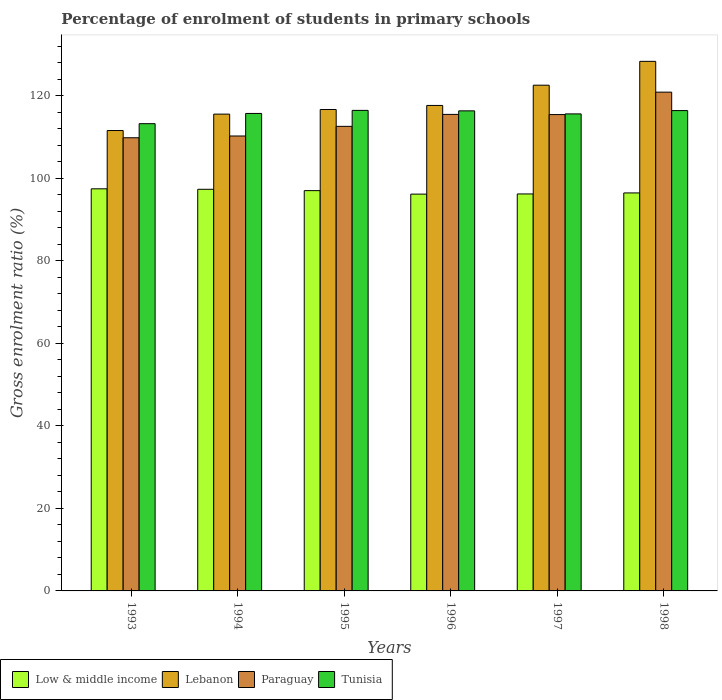How many different coloured bars are there?
Provide a succinct answer. 4. How many groups of bars are there?
Offer a terse response. 6. Are the number of bars per tick equal to the number of legend labels?
Give a very brief answer. Yes. Are the number of bars on each tick of the X-axis equal?
Offer a terse response. Yes. How many bars are there on the 3rd tick from the right?
Keep it short and to the point. 4. What is the percentage of students enrolled in primary schools in Paraguay in 1997?
Ensure brevity in your answer.  115.43. Across all years, what is the maximum percentage of students enrolled in primary schools in Low & middle income?
Provide a short and direct response. 97.44. Across all years, what is the minimum percentage of students enrolled in primary schools in Paraguay?
Your answer should be compact. 109.81. In which year was the percentage of students enrolled in primary schools in Tunisia maximum?
Provide a succinct answer. 1995. What is the total percentage of students enrolled in primary schools in Lebanon in the graph?
Offer a very short reply. 712.27. What is the difference between the percentage of students enrolled in primary schools in Lebanon in 1995 and that in 1996?
Ensure brevity in your answer.  -0.98. What is the difference between the percentage of students enrolled in primary schools in Paraguay in 1993 and the percentage of students enrolled in primary schools in Lebanon in 1995?
Offer a terse response. -6.85. What is the average percentage of students enrolled in primary schools in Lebanon per year?
Keep it short and to the point. 118.71. In the year 1993, what is the difference between the percentage of students enrolled in primary schools in Low & middle income and percentage of students enrolled in primary schools in Paraguay?
Your response must be concise. -12.37. What is the ratio of the percentage of students enrolled in primary schools in Lebanon in 1995 to that in 1996?
Provide a short and direct response. 0.99. Is the percentage of students enrolled in primary schools in Low & middle income in 1994 less than that in 1996?
Offer a terse response. No. Is the difference between the percentage of students enrolled in primary schools in Low & middle income in 1993 and 1996 greater than the difference between the percentage of students enrolled in primary schools in Paraguay in 1993 and 1996?
Give a very brief answer. Yes. What is the difference between the highest and the second highest percentage of students enrolled in primary schools in Paraguay?
Provide a short and direct response. 5.39. What is the difference between the highest and the lowest percentage of students enrolled in primary schools in Low & middle income?
Ensure brevity in your answer.  1.28. Is the sum of the percentage of students enrolled in primary schools in Paraguay in 1993 and 1998 greater than the maximum percentage of students enrolled in primary schools in Tunisia across all years?
Ensure brevity in your answer.  Yes. Is it the case that in every year, the sum of the percentage of students enrolled in primary schools in Lebanon and percentage of students enrolled in primary schools in Paraguay is greater than the sum of percentage of students enrolled in primary schools in Tunisia and percentage of students enrolled in primary schools in Low & middle income?
Ensure brevity in your answer.  No. What does the 2nd bar from the left in 1996 represents?
Your answer should be compact. Lebanon. What does the 2nd bar from the right in 1994 represents?
Your answer should be compact. Paraguay. Is it the case that in every year, the sum of the percentage of students enrolled in primary schools in Tunisia and percentage of students enrolled in primary schools in Paraguay is greater than the percentage of students enrolled in primary schools in Low & middle income?
Provide a short and direct response. Yes. How many bars are there?
Your response must be concise. 24. Are all the bars in the graph horizontal?
Ensure brevity in your answer.  No. Are the values on the major ticks of Y-axis written in scientific E-notation?
Provide a succinct answer. No. Does the graph contain grids?
Your answer should be very brief. No. Where does the legend appear in the graph?
Give a very brief answer. Bottom left. How many legend labels are there?
Your response must be concise. 4. How are the legend labels stacked?
Give a very brief answer. Horizontal. What is the title of the graph?
Offer a very short reply. Percentage of enrolment of students in primary schools. Does "Cayman Islands" appear as one of the legend labels in the graph?
Make the answer very short. No. What is the label or title of the X-axis?
Your answer should be very brief. Years. What is the Gross enrolment ratio (%) of Low & middle income in 1993?
Your response must be concise. 97.44. What is the Gross enrolment ratio (%) in Lebanon in 1993?
Ensure brevity in your answer.  111.56. What is the Gross enrolment ratio (%) in Paraguay in 1993?
Give a very brief answer. 109.81. What is the Gross enrolment ratio (%) of Tunisia in 1993?
Give a very brief answer. 113.22. What is the Gross enrolment ratio (%) in Low & middle income in 1994?
Offer a terse response. 97.32. What is the Gross enrolment ratio (%) of Lebanon in 1994?
Keep it short and to the point. 115.54. What is the Gross enrolment ratio (%) in Paraguay in 1994?
Provide a succinct answer. 110.24. What is the Gross enrolment ratio (%) in Tunisia in 1994?
Offer a very short reply. 115.7. What is the Gross enrolment ratio (%) of Low & middle income in 1995?
Your answer should be very brief. 97. What is the Gross enrolment ratio (%) of Lebanon in 1995?
Your answer should be very brief. 116.66. What is the Gross enrolment ratio (%) of Paraguay in 1995?
Provide a short and direct response. 112.57. What is the Gross enrolment ratio (%) in Tunisia in 1995?
Keep it short and to the point. 116.44. What is the Gross enrolment ratio (%) of Low & middle income in 1996?
Your response must be concise. 96.15. What is the Gross enrolment ratio (%) in Lebanon in 1996?
Give a very brief answer. 117.64. What is the Gross enrolment ratio (%) of Paraguay in 1996?
Give a very brief answer. 115.47. What is the Gross enrolment ratio (%) in Tunisia in 1996?
Make the answer very short. 116.33. What is the Gross enrolment ratio (%) of Low & middle income in 1997?
Offer a terse response. 96.2. What is the Gross enrolment ratio (%) of Lebanon in 1997?
Offer a very short reply. 122.55. What is the Gross enrolment ratio (%) of Paraguay in 1997?
Keep it short and to the point. 115.43. What is the Gross enrolment ratio (%) in Tunisia in 1997?
Give a very brief answer. 115.59. What is the Gross enrolment ratio (%) in Low & middle income in 1998?
Provide a short and direct response. 96.44. What is the Gross enrolment ratio (%) of Lebanon in 1998?
Keep it short and to the point. 128.32. What is the Gross enrolment ratio (%) of Paraguay in 1998?
Provide a succinct answer. 120.86. What is the Gross enrolment ratio (%) of Tunisia in 1998?
Make the answer very short. 116.39. Across all years, what is the maximum Gross enrolment ratio (%) of Low & middle income?
Give a very brief answer. 97.44. Across all years, what is the maximum Gross enrolment ratio (%) in Lebanon?
Make the answer very short. 128.32. Across all years, what is the maximum Gross enrolment ratio (%) of Paraguay?
Ensure brevity in your answer.  120.86. Across all years, what is the maximum Gross enrolment ratio (%) in Tunisia?
Make the answer very short. 116.44. Across all years, what is the minimum Gross enrolment ratio (%) of Low & middle income?
Offer a terse response. 96.15. Across all years, what is the minimum Gross enrolment ratio (%) of Lebanon?
Offer a terse response. 111.56. Across all years, what is the minimum Gross enrolment ratio (%) in Paraguay?
Keep it short and to the point. 109.81. Across all years, what is the minimum Gross enrolment ratio (%) of Tunisia?
Your response must be concise. 113.22. What is the total Gross enrolment ratio (%) in Low & middle income in the graph?
Ensure brevity in your answer.  580.55. What is the total Gross enrolment ratio (%) in Lebanon in the graph?
Keep it short and to the point. 712.27. What is the total Gross enrolment ratio (%) of Paraguay in the graph?
Give a very brief answer. 684.38. What is the total Gross enrolment ratio (%) of Tunisia in the graph?
Your response must be concise. 693.68. What is the difference between the Gross enrolment ratio (%) in Low & middle income in 1993 and that in 1994?
Your answer should be compact. 0.11. What is the difference between the Gross enrolment ratio (%) in Lebanon in 1993 and that in 1994?
Ensure brevity in your answer.  -3.98. What is the difference between the Gross enrolment ratio (%) in Paraguay in 1993 and that in 1994?
Ensure brevity in your answer.  -0.43. What is the difference between the Gross enrolment ratio (%) in Tunisia in 1993 and that in 1994?
Keep it short and to the point. -2.48. What is the difference between the Gross enrolment ratio (%) in Low & middle income in 1993 and that in 1995?
Make the answer very short. 0.44. What is the difference between the Gross enrolment ratio (%) of Lebanon in 1993 and that in 1995?
Your response must be concise. -5.09. What is the difference between the Gross enrolment ratio (%) of Paraguay in 1993 and that in 1995?
Provide a short and direct response. -2.76. What is the difference between the Gross enrolment ratio (%) of Tunisia in 1993 and that in 1995?
Keep it short and to the point. -3.22. What is the difference between the Gross enrolment ratio (%) of Low & middle income in 1993 and that in 1996?
Your response must be concise. 1.28. What is the difference between the Gross enrolment ratio (%) of Lebanon in 1993 and that in 1996?
Offer a terse response. -6.07. What is the difference between the Gross enrolment ratio (%) of Paraguay in 1993 and that in 1996?
Your response must be concise. -5.66. What is the difference between the Gross enrolment ratio (%) in Tunisia in 1993 and that in 1996?
Ensure brevity in your answer.  -3.11. What is the difference between the Gross enrolment ratio (%) of Low & middle income in 1993 and that in 1997?
Offer a very short reply. 1.24. What is the difference between the Gross enrolment ratio (%) in Lebanon in 1993 and that in 1997?
Your response must be concise. -10.98. What is the difference between the Gross enrolment ratio (%) of Paraguay in 1993 and that in 1997?
Make the answer very short. -5.62. What is the difference between the Gross enrolment ratio (%) of Tunisia in 1993 and that in 1997?
Offer a very short reply. -2.37. What is the difference between the Gross enrolment ratio (%) in Low & middle income in 1993 and that in 1998?
Offer a terse response. 1. What is the difference between the Gross enrolment ratio (%) in Lebanon in 1993 and that in 1998?
Your answer should be very brief. -16.76. What is the difference between the Gross enrolment ratio (%) of Paraguay in 1993 and that in 1998?
Offer a terse response. -11.05. What is the difference between the Gross enrolment ratio (%) of Tunisia in 1993 and that in 1998?
Your answer should be very brief. -3.17. What is the difference between the Gross enrolment ratio (%) in Low & middle income in 1994 and that in 1995?
Keep it short and to the point. 0.33. What is the difference between the Gross enrolment ratio (%) in Lebanon in 1994 and that in 1995?
Make the answer very short. -1.12. What is the difference between the Gross enrolment ratio (%) in Paraguay in 1994 and that in 1995?
Offer a very short reply. -2.34. What is the difference between the Gross enrolment ratio (%) of Tunisia in 1994 and that in 1995?
Keep it short and to the point. -0.74. What is the difference between the Gross enrolment ratio (%) in Low & middle income in 1994 and that in 1996?
Offer a very short reply. 1.17. What is the difference between the Gross enrolment ratio (%) of Lebanon in 1994 and that in 1996?
Provide a succinct answer. -2.1. What is the difference between the Gross enrolment ratio (%) in Paraguay in 1994 and that in 1996?
Keep it short and to the point. -5.23. What is the difference between the Gross enrolment ratio (%) in Tunisia in 1994 and that in 1996?
Provide a succinct answer. -0.63. What is the difference between the Gross enrolment ratio (%) in Low & middle income in 1994 and that in 1997?
Give a very brief answer. 1.13. What is the difference between the Gross enrolment ratio (%) in Lebanon in 1994 and that in 1997?
Offer a very short reply. -7.01. What is the difference between the Gross enrolment ratio (%) in Paraguay in 1994 and that in 1997?
Ensure brevity in your answer.  -5.19. What is the difference between the Gross enrolment ratio (%) of Tunisia in 1994 and that in 1997?
Make the answer very short. 0.11. What is the difference between the Gross enrolment ratio (%) in Low & middle income in 1994 and that in 1998?
Keep it short and to the point. 0.88. What is the difference between the Gross enrolment ratio (%) of Lebanon in 1994 and that in 1998?
Offer a very short reply. -12.78. What is the difference between the Gross enrolment ratio (%) of Paraguay in 1994 and that in 1998?
Ensure brevity in your answer.  -10.62. What is the difference between the Gross enrolment ratio (%) in Tunisia in 1994 and that in 1998?
Offer a very short reply. -0.69. What is the difference between the Gross enrolment ratio (%) of Low & middle income in 1995 and that in 1996?
Your response must be concise. 0.84. What is the difference between the Gross enrolment ratio (%) of Lebanon in 1995 and that in 1996?
Your response must be concise. -0.98. What is the difference between the Gross enrolment ratio (%) of Paraguay in 1995 and that in 1996?
Offer a terse response. -2.9. What is the difference between the Gross enrolment ratio (%) in Tunisia in 1995 and that in 1996?
Offer a terse response. 0.11. What is the difference between the Gross enrolment ratio (%) in Low & middle income in 1995 and that in 1997?
Offer a terse response. 0.8. What is the difference between the Gross enrolment ratio (%) of Lebanon in 1995 and that in 1997?
Provide a short and direct response. -5.89. What is the difference between the Gross enrolment ratio (%) in Paraguay in 1995 and that in 1997?
Make the answer very short. -2.86. What is the difference between the Gross enrolment ratio (%) in Tunisia in 1995 and that in 1997?
Make the answer very short. 0.85. What is the difference between the Gross enrolment ratio (%) of Low & middle income in 1995 and that in 1998?
Your answer should be compact. 0.56. What is the difference between the Gross enrolment ratio (%) of Lebanon in 1995 and that in 1998?
Ensure brevity in your answer.  -11.67. What is the difference between the Gross enrolment ratio (%) of Paraguay in 1995 and that in 1998?
Give a very brief answer. -8.29. What is the difference between the Gross enrolment ratio (%) in Tunisia in 1995 and that in 1998?
Your response must be concise. 0.05. What is the difference between the Gross enrolment ratio (%) of Low & middle income in 1996 and that in 1997?
Offer a very short reply. -0.04. What is the difference between the Gross enrolment ratio (%) of Lebanon in 1996 and that in 1997?
Give a very brief answer. -4.91. What is the difference between the Gross enrolment ratio (%) in Paraguay in 1996 and that in 1997?
Ensure brevity in your answer.  0.04. What is the difference between the Gross enrolment ratio (%) of Tunisia in 1996 and that in 1997?
Offer a very short reply. 0.74. What is the difference between the Gross enrolment ratio (%) in Low & middle income in 1996 and that in 1998?
Keep it short and to the point. -0.29. What is the difference between the Gross enrolment ratio (%) in Lebanon in 1996 and that in 1998?
Provide a short and direct response. -10.69. What is the difference between the Gross enrolment ratio (%) of Paraguay in 1996 and that in 1998?
Ensure brevity in your answer.  -5.39. What is the difference between the Gross enrolment ratio (%) of Tunisia in 1996 and that in 1998?
Keep it short and to the point. -0.06. What is the difference between the Gross enrolment ratio (%) of Low & middle income in 1997 and that in 1998?
Your answer should be very brief. -0.24. What is the difference between the Gross enrolment ratio (%) of Lebanon in 1997 and that in 1998?
Keep it short and to the point. -5.78. What is the difference between the Gross enrolment ratio (%) of Paraguay in 1997 and that in 1998?
Your answer should be compact. -5.43. What is the difference between the Gross enrolment ratio (%) of Tunisia in 1997 and that in 1998?
Offer a terse response. -0.8. What is the difference between the Gross enrolment ratio (%) of Low & middle income in 1993 and the Gross enrolment ratio (%) of Lebanon in 1994?
Offer a terse response. -18.1. What is the difference between the Gross enrolment ratio (%) of Low & middle income in 1993 and the Gross enrolment ratio (%) of Paraguay in 1994?
Your response must be concise. -12.8. What is the difference between the Gross enrolment ratio (%) of Low & middle income in 1993 and the Gross enrolment ratio (%) of Tunisia in 1994?
Provide a short and direct response. -18.26. What is the difference between the Gross enrolment ratio (%) in Lebanon in 1993 and the Gross enrolment ratio (%) in Paraguay in 1994?
Provide a short and direct response. 1.33. What is the difference between the Gross enrolment ratio (%) of Lebanon in 1993 and the Gross enrolment ratio (%) of Tunisia in 1994?
Offer a terse response. -4.14. What is the difference between the Gross enrolment ratio (%) in Paraguay in 1993 and the Gross enrolment ratio (%) in Tunisia in 1994?
Provide a short and direct response. -5.89. What is the difference between the Gross enrolment ratio (%) in Low & middle income in 1993 and the Gross enrolment ratio (%) in Lebanon in 1995?
Provide a succinct answer. -19.22. What is the difference between the Gross enrolment ratio (%) of Low & middle income in 1993 and the Gross enrolment ratio (%) of Paraguay in 1995?
Your response must be concise. -15.14. What is the difference between the Gross enrolment ratio (%) in Low & middle income in 1993 and the Gross enrolment ratio (%) in Tunisia in 1995?
Give a very brief answer. -19.01. What is the difference between the Gross enrolment ratio (%) in Lebanon in 1993 and the Gross enrolment ratio (%) in Paraguay in 1995?
Your answer should be compact. -1.01. What is the difference between the Gross enrolment ratio (%) of Lebanon in 1993 and the Gross enrolment ratio (%) of Tunisia in 1995?
Offer a very short reply. -4.88. What is the difference between the Gross enrolment ratio (%) of Paraguay in 1993 and the Gross enrolment ratio (%) of Tunisia in 1995?
Your answer should be compact. -6.63. What is the difference between the Gross enrolment ratio (%) of Low & middle income in 1993 and the Gross enrolment ratio (%) of Lebanon in 1996?
Offer a terse response. -20.2. What is the difference between the Gross enrolment ratio (%) of Low & middle income in 1993 and the Gross enrolment ratio (%) of Paraguay in 1996?
Your answer should be very brief. -18.03. What is the difference between the Gross enrolment ratio (%) of Low & middle income in 1993 and the Gross enrolment ratio (%) of Tunisia in 1996?
Provide a succinct answer. -18.89. What is the difference between the Gross enrolment ratio (%) in Lebanon in 1993 and the Gross enrolment ratio (%) in Paraguay in 1996?
Keep it short and to the point. -3.9. What is the difference between the Gross enrolment ratio (%) in Lebanon in 1993 and the Gross enrolment ratio (%) in Tunisia in 1996?
Your answer should be compact. -4.76. What is the difference between the Gross enrolment ratio (%) of Paraguay in 1993 and the Gross enrolment ratio (%) of Tunisia in 1996?
Make the answer very short. -6.52. What is the difference between the Gross enrolment ratio (%) of Low & middle income in 1993 and the Gross enrolment ratio (%) of Lebanon in 1997?
Offer a terse response. -25.11. What is the difference between the Gross enrolment ratio (%) of Low & middle income in 1993 and the Gross enrolment ratio (%) of Paraguay in 1997?
Give a very brief answer. -17.99. What is the difference between the Gross enrolment ratio (%) in Low & middle income in 1993 and the Gross enrolment ratio (%) in Tunisia in 1997?
Keep it short and to the point. -18.15. What is the difference between the Gross enrolment ratio (%) of Lebanon in 1993 and the Gross enrolment ratio (%) of Paraguay in 1997?
Offer a terse response. -3.87. What is the difference between the Gross enrolment ratio (%) of Lebanon in 1993 and the Gross enrolment ratio (%) of Tunisia in 1997?
Provide a short and direct response. -4.03. What is the difference between the Gross enrolment ratio (%) of Paraguay in 1993 and the Gross enrolment ratio (%) of Tunisia in 1997?
Make the answer very short. -5.78. What is the difference between the Gross enrolment ratio (%) of Low & middle income in 1993 and the Gross enrolment ratio (%) of Lebanon in 1998?
Offer a terse response. -30.89. What is the difference between the Gross enrolment ratio (%) of Low & middle income in 1993 and the Gross enrolment ratio (%) of Paraguay in 1998?
Offer a very short reply. -23.42. What is the difference between the Gross enrolment ratio (%) in Low & middle income in 1993 and the Gross enrolment ratio (%) in Tunisia in 1998?
Offer a very short reply. -18.96. What is the difference between the Gross enrolment ratio (%) in Lebanon in 1993 and the Gross enrolment ratio (%) in Paraguay in 1998?
Provide a short and direct response. -9.3. What is the difference between the Gross enrolment ratio (%) of Lebanon in 1993 and the Gross enrolment ratio (%) of Tunisia in 1998?
Provide a succinct answer. -4.83. What is the difference between the Gross enrolment ratio (%) of Paraguay in 1993 and the Gross enrolment ratio (%) of Tunisia in 1998?
Provide a short and direct response. -6.58. What is the difference between the Gross enrolment ratio (%) in Low & middle income in 1994 and the Gross enrolment ratio (%) in Lebanon in 1995?
Offer a terse response. -19.33. What is the difference between the Gross enrolment ratio (%) in Low & middle income in 1994 and the Gross enrolment ratio (%) in Paraguay in 1995?
Provide a succinct answer. -15.25. What is the difference between the Gross enrolment ratio (%) in Low & middle income in 1994 and the Gross enrolment ratio (%) in Tunisia in 1995?
Ensure brevity in your answer.  -19.12. What is the difference between the Gross enrolment ratio (%) in Lebanon in 1994 and the Gross enrolment ratio (%) in Paraguay in 1995?
Give a very brief answer. 2.97. What is the difference between the Gross enrolment ratio (%) in Lebanon in 1994 and the Gross enrolment ratio (%) in Tunisia in 1995?
Offer a terse response. -0.9. What is the difference between the Gross enrolment ratio (%) in Paraguay in 1994 and the Gross enrolment ratio (%) in Tunisia in 1995?
Keep it short and to the point. -6.21. What is the difference between the Gross enrolment ratio (%) of Low & middle income in 1994 and the Gross enrolment ratio (%) of Lebanon in 1996?
Your answer should be very brief. -20.32. What is the difference between the Gross enrolment ratio (%) of Low & middle income in 1994 and the Gross enrolment ratio (%) of Paraguay in 1996?
Your answer should be very brief. -18.15. What is the difference between the Gross enrolment ratio (%) in Low & middle income in 1994 and the Gross enrolment ratio (%) in Tunisia in 1996?
Provide a short and direct response. -19.01. What is the difference between the Gross enrolment ratio (%) of Lebanon in 1994 and the Gross enrolment ratio (%) of Paraguay in 1996?
Give a very brief answer. 0.07. What is the difference between the Gross enrolment ratio (%) of Lebanon in 1994 and the Gross enrolment ratio (%) of Tunisia in 1996?
Your response must be concise. -0.79. What is the difference between the Gross enrolment ratio (%) in Paraguay in 1994 and the Gross enrolment ratio (%) in Tunisia in 1996?
Give a very brief answer. -6.09. What is the difference between the Gross enrolment ratio (%) of Low & middle income in 1994 and the Gross enrolment ratio (%) of Lebanon in 1997?
Offer a terse response. -25.22. What is the difference between the Gross enrolment ratio (%) in Low & middle income in 1994 and the Gross enrolment ratio (%) in Paraguay in 1997?
Offer a terse response. -18.11. What is the difference between the Gross enrolment ratio (%) in Low & middle income in 1994 and the Gross enrolment ratio (%) in Tunisia in 1997?
Keep it short and to the point. -18.27. What is the difference between the Gross enrolment ratio (%) of Lebanon in 1994 and the Gross enrolment ratio (%) of Paraguay in 1997?
Offer a terse response. 0.11. What is the difference between the Gross enrolment ratio (%) of Lebanon in 1994 and the Gross enrolment ratio (%) of Tunisia in 1997?
Provide a succinct answer. -0.05. What is the difference between the Gross enrolment ratio (%) of Paraguay in 1994 and the Gross enrolment ratio (%) of Tunisia in 1997?
Provide a succinct answer. -5.35. What is the difference between the Gross enrolment ratio (%) of Low & middle income in 1994 and the Gross enrolment ratio (%) of Lebanon in 1998?
Keep it short and to the point. -31. What is the difference between the Gross enrolment ratio (%) in Low & middle income in 1994 and the Gross enrolment ratio (%) in Paraguay in 1998?
Your answer should be compact. -23.54. What is the difference between the Gross enrolment ratio (%) of Low & middle income in 1994 and the Gross enrolment ratio (%) of Tunisia in 1998?
Provide a succinct answer. -19.07. What is the difference between the Gross enrolment ratio (%) in Lebanon in 1994 and the Gross enrolment ratio (%) in Paraguay in 1998?
Provide a succinct answer. -5.32. What is the difference between the Gross enrolment ratio (%) of Lebanon in 1994 and the Gross enrolment ratio (%) of Tunisia in 1998?
Keep it short and to the point. -0.85. What is the difference between the Gross enrolment ratio (%) of Paraguay in 1994 and the Gross enrolment ratio (%) of Tunisia in 1998?
Offer a very short reply. -6.16. What is the difference between the Gross enrolment ratio (%) in Low & middle income in 1995 and the Gross enrolment ratio (%) in Lebanon in 1996?
Provide a short and direct response. -20.64. What is the difference between the Gross enrolment ratio (%) of Low & middle income in 1995 and the Gross enrolment ratio (%) of Paraguay in 1996?
Provide a short and direct response. -18.47. What is the difference between the Gross enrolment ratio (%) of Low & middle income in 1995 and the Gross enrolment ratio (%) of Tunisia in 1996?
Your answer should be compact. -19.33. What is the difference between the Gross enrolment ratio (%) of Lebanon in 1995 and the Gross enrolment ratio (%) of Paraguay in 1996?
Your answer should be compact. 1.19. What is the difference between the Gross enrolment ratio (%) of Lebanon in 1995 and the Gross enrolment ratio (%) of Tunisia in 1996?
Provide a succinct answer. 0.33. What is the difference between the Gross enrolment ratio (%) in Paraguay in 1995 and the Gross enrolment ratio (%) in Tunisia in 1996?
Offer a terse response. -3.76. What is the difference between the Gross enrolment ratio (%) of Low & middle income in 1995 and the Gross enrolment ratio (%) of Lebanon in 1997?
Keep it short and to the point. -25.55. What is the difference between the Gross enrolment ratio (%) of Low & middle income in 1995 and the Gross enrolment ratio (%) of Paraguay in 1997?
Keep it short and to the point. -18.43. What is the difference between the Gross enrolment ratio (%) in Low & middle income in 1995 and the Gross enrolment ratio (%) in Tunisia in 1997?
Make the answer very short. -18.59. What is the difference between the Gross enrolment ratio (%) of Lebanon in 1995 and the Gross enrolment ratio (%) of Paraguay in 1997?
Your response must be concise. 1.23. What is the difference between the Gross enrolment ratio (%) of Lebanon in 1995 and the Gross enrolment ratio (%) of Tunisia in 1997?
Offer a very short reply. 1.07. What is the difference between the Gross enrolment ratio (%) of Paraguay in 1995 and the Gross enrolment ratio (%) of Tunisia in 1997?
Provide a short and direct response. -3.02. What is the difference between the Gross enrolment ratio (%) in Low & middle income in 1995 and the Gross enrolment ratio (%) in Lebanon in 1998?
Your response must be concise. -31.33. What is the difference between the Gross enrolment ratio (%) in Low & middle income in 1995 and the Gross enrolment ratio (%) in Paraguay in 1998?
Your answer should be compact. -23.86. What is the difference between the Gross enrolment ratio (%) of Low & middle income in 1995 and the Gross enrolment ratio (%) of Tunisia in 1998?
Offer a terse response. -19.4. What is the difference between the Gross enrolment ratio (%) of Lebanon in 1995 and the Gross enrolment ratio (%) of Paraguay in 1998?
Ensure brevity in your answer.  -4.2. What is the difference between the Gross enrolment ratio (%) of Lebanon in 1995 and the Gross enrolment ratio (%) of Tunisia in 1998?
Provide a short and direct response. 0.26. What is the difference between the Gross enrolment ratio (%) in Paraguay in 1995 and the Gross enrolment ratio (%) in Tunisia in 1998?
Make the answer very short. -3.82. What is the difference between the Gross enrolment ratio (%) in Low & middle income in 1996 and the Gross enrolment ratio (%) in Lebanon in 1997?
Make the answer very short. -26.39. What is the difference between the Gross enrolment ratio (%) in Low & middle income in 1996 and the Gross enrolment ratio (%) in Paraguay in 1997?
Ensure brevity in your answer.  -19.28. What is the difference between the Gross enrolment ratio (%) of Low & middle income in 1996 and the Gross enrolment ratio (%) of Tunisia in 1997?
Your answer should be very brief. -19.44. What is the difference between the Gross enrolment ratio (%) in Lebanon in 1996 and the Gross enrolment ratio (%) in Paraguay in 1997?
Give a very brief answer. 2.21. What is the difference between the Gross enrolment ratio (%) in Lebanon in 1996 and the Gross enrolment ratio (%) in Tunisia in 1997?
Your answer should be very brief. 2.05. What is the difference between the Gross enrolment ratio (%) of Paraguay in 1996 and the Gross enrolment ratio (%) of Tunisia in 1997?
Make the answer very short. -0.12. What is the difference between the Gross enrolment ratio (%) of Low & middle income in 1996 and the Gross enrolment ratio (%) of Lebanon in 1998?
Your answer should be compact. -32.17. What is the difference between the Gross enrolment ratio (%) of Low & middle income in 1996 and the Gross enrolment ratio (%) of Paraguay in 1998?
Offer a terse response. -24.71. What is the difference between the Gross enrolment ratio (%) of Low & middle income in 1996 and the Gross enrolment ratio (%) of Tunisia in 1998?
Keep it short and to the point. -20.24. What is the difference between the Gross enrolment ratio (%) in Lebanon in 1996 and the Gross enrolment ratio (%) in Paraguay in 1998?
Keep it short and to the point. -3.22. What is the difference between the Gross enrolment ratio (%) of Lebanon in 1996 and the Gross enrolment ratio (%) of Tunisia in 1998?
Ensure brevity in your answer.  1.25. What is the difference between the Gross enrolment ratio (%) of Paraguay in 1996 and the Gross enrolment ratio (%) of Tunisia in 1998?
Your answer should be very brief. -0.92. What is the difference between the Gross enrolment ratio (%) of Low & middle income in 1997 and the Gross enrolment ratio (%) of Lebanon in 1998?
Keep it short and to the point. -32.13. What is the difference between the Gross enrolment ratio (%) of Low & middle income in 1997 and the Gross enrolment ratio (%) of Paraguay in 1998?
Make the answer very short. -24.66. What is the difference between the Gross enrolment ratio (%) in Low & middle income in 1997 and the Gross enrolment ratio (%) in Tunisia in 1998?
Your answer should be compact. -20.2. What is the difference between the Gross enrolment ratio (%) in Lebanon in 1997 and the Gross enrolment ratio (%) in Paraguay in 1998?
Your answer should be very brief. 1.69. What is the difference between the Gross enrolment ratio (%) in Lebanon in 1997 and the Gross enrolment ratio (%) in Tunisia in 1998?
Offer a very short reply. 6.15. What is the difference between the Gross enrolment ratio (%) in Paraguay in 1997 and the Gross enrolment ratio (%) in Tunisia in 1998?
Keep it short and to the point. -0.96. What is the average Gross enrolment ratio (%) of Low & middle income per year?
Keep it short and to the point. 96.76. What is the average Gross enrolment ratio (%) in Lebanon per year?
Offer a very short reply. 118.71. What is the average Gross enrolment ratio (%) of Paraguay per year?
Ensure brevity in your answer.  114.06. What is the average Gross enrolment ratio (%) of Tunisia per year?
Provide a short and direct response. 115.61. In the year 1993, what is the difference between the Gross enrolment ratio (%) of Low & middle income and Gross enrolment ratio (%) of Lebanon?
Provide a succinct answer. -14.13. In the year 1993, what is the difference between the Gross enrolment ratio (%) of Low & middle income and Gross enrolment ratio (%) of Paraguay?
Offer a very short reply. -12.37. In the year 1993, what is the difference between the Gross enrolment ratio (%) of Low & middle income and Gross enrolment ratio (%) of Tunisia?
Your answer should be compact. -15.78. In the year 1993, what is the difference between the Gross enrolment ratio (%) in Lebanon and Gross enrolment ratio (%) in Paraguay?
Your answer should be compact. 1.75. In the year 1993, what is the difference between the Gross enrolment ratio (%) of Lebanon and Gross enrolment ratio (%) of Tunisia?
Your answer should be very brief. -1.66. In the year 1993, what is the difference between the Gross enrolment ratio (%) in Paraguay and Gross enrolment ratio (%) in Tunisia?
Your answer should be very brief. -3.41. In the year 1994, what is the difference between the Gross enrolment ratio (%) in Low & middle income and Gross enrolment ratio (%) in Lebanon?
Your response must be concise. -18.22. In the year 1994, what is the difference between the Gross enrolment ratio (%) of Low & middle income and Gross enrolment ratio (%) of Paraguay?
Offer a very short reply. -12.91. In the year 1994, what is the difference between the Gross enrolment ratio (%) of Low & middle income and Gross enrolment ratio (%) of Tunisia?
Offer a very short reply. -18.38. In the year 1994, what is the difference between the Gross enrolment ratio (%) of Lebanon and Gross enrolment ratio (%) of Paraguay?
Provide a short and direct response. 5.3. In the year 1994, what is the difference between the Gross enrolment ratio (%) of Lebanon and Gross enrolment ratio (%) of Tunisia?
Offer a very short reply. -0.16. In the year 1994, what is the difference between the Gross enrolment ratio (%) of Paraguay and Gross enrolment ratio (%) of Tunisia?
Offer a terse response. -5.46. In the year 1995, what is the difference between the Gross enrolment ratio (%) of Low & middle income and Gross enrolment ratio (%) of Lebanon?
Keep it short and to the point. -19.66. In the year 1995, what is the difference between the Gross enrolment ratio (%) of Low & middle income and Gross enrolment ratio (%) of Paraguay?
Give a very brief answer. -15.58. In the year 1995, what is the difference between the Gross enrolment ratio (%) of Low & middle income and Gross enrolment ratio (%) of Tunisia?
Give a very brief answer. -19.45. In the year 1995, what is the difference between the Gross enrolment ratio (%) in Lebanon and Gross enrolment ratio (%) in Paraguay?
Offer a very short reply. 4.08. In the year 1995, what is the difference between the Gross enrolment ratio (%) in Lebanon and Gross enrolment ratio (%) in Tunisia?
Ensure brevity in your answer.  0.21. In the year 1995, what is the difference between the Gross enrolment ratio (%) of Paraguay and Gross enrolment ratio (%) of Tunisia?
Your answer should be compact. -3.87. In the year 1996, what is the difference between the Gross enrolment ratio (%) in Low & middle income and Gross enrolment ratio (%) in Lebanon?
Offer a terse response. -21.48. In the year 1996, what is the difference between the Gross enrolment ratio (%) of Low & middle income and Gross enrolment ratio (%) of Paraguay?
Keep it short and to the point. -19.31. In the year 1996, what is the difference between the Gross enrolment ratio (%) of Low & middle income and Gross enrolment ratio (%) of Tunisia?
Offer a very short reply. -20.17. In the year 1996, what is the difference between the Gross enrolment ratio (%) of Lebanon and Gross enrolment ratio (%) of Paraguay?
Give a very brief answer. 2.17. In the year 1996, what is the difference between the Gross enrolment ratio (%) in Lebanon and Gross enrolment ratio (%) in Tunisia?
Make the answer very short. 1.31. In the year 1996, what is the difference between the Gross enrolment ratio (%) in Paraguay and Gross enrolment ratio (%) in Tunisia?
Provide a short and direct response. -0.86. In the year 1997, what is the difference between the Gross enrolment ratio (%) in Low & middle income and Gross enrolment ratio (%) in Lebanon?
Your answer should be very brief. -26.35. In the year 1997, what is the difference between the Gross enrolment ratio (%) in Low & middle income and Gross enrolment ratio (%) in Paraguay?
Your answer should be very brief. -19.23. In the year 1997, what is the difference between the Gross enrolment ratio (%) of Low & middle income and Gross enrolment ratio (%) of Tunisia?
Provide a succinct answer. -19.4. In the year 1997, what is the difference between the Gross enrolment ratio (%) of Lebanon and Gross enrolment ratio (%) of Paraguay?
Give a very brief answer. 7.12. In the year 1997, what is the difference between the Gross enrolment ratio (%) in Lebanon and Gross enrolment ratio (%) in Tunisia?
Provide a short and direct response. 6.95. In the year 1997, what is the difference between the Gross enrolment ratio (%) of Paraguay and Gross enrolment ratio (%) of Tunisia?
Provide a succinct answer. -0.16. In the year 1998, what is the difference between the Gross enrolment ratio (%) of Low & middle income and Gross enrolment ratio (%) of Lebanon?
Ensure brevity in your answer.  -31.88. In the year 1998, what is the difference between the Gross enrolment ratio (%) in Low & middle income and Gross enrolment ratio (%) in Paraguay?
Your answer should be compact. -24.42. In the year 1998, what is the difference between the Gross enrolment ratio (%) of Low & middle income and Gross enrolment ratio (%) of Tunisia?
Provide a short and direct response. -19.95. In the year 1998, what is the difference between the Gross enrolment ratio (%) of Lebanon and Gross enrolment ratio (%) of Paraguay?
Provide a short and direct response. 7.46. In the year 1998, what is the difference between the Gross enrolment ratio (%) in Lebanon and Gross enrolment ratio (%) in Tunisia?
Make the answer very short. 11.93. In the year 1998, what is the difference between the Gross enrolment ratio (%) in Paraguay and Gross enrolment ratio (%) in Tunisia?
Ensure brevity in your answer.  4.47. What is the ratio of the Gross enrolment ratio (%) of Lebanon in 1993 to that in 1994?
Provide a short and direct response. 0.97. What is the ratio of the Gross enrolment ratio (%) of Paraguay in 1993 to that in 1994?
Keep it short and to the point. 1. What is the ratio of the Gross enrolment ratio (%) of Tunisia in 1993 to that in 1994?
Ensure brevity in your answer.  0.98. What is the ratio of the Gross enrolment ratio (%) in Low & middle income in 1993 to that in 1995?
Provide a succinct answer. 1. What is the ratio of the Gross enrolment ratio (%) in Lebanon in 1993 to that in 1995?
Offer a very short reply. 0.96. What is the ratio of the Gross enrolment ratio (%) in Paraguay in 1993 to that in 1995?
Your response must be concise. 0.98. What is the ratio of the Gross enrolment ratio (%) of Tunisia in 1993 to that in 1995?
Provide a short and direct response. 0.97. What is the ratio of the Gross enrolment ratio (%) of Low & middle income in 1993 to that in 1996?
Make the answer very short. 1.01. What is the ratio of the Gross enrolment ratio (%) of Lebanon in 1993 to that in 1996?
Keep it short and to the point. 0.95. What is the ratio of the Gross enrolment ratio (%) in Paraguay in 1993 to that in 1996?
Provide a succinct answer. 0.95. What is the ratio of the Gross enrolment ratio (%) of Tunisia in 1993 to that in 1996?
Your response must be concise. 0.97. What is the ratio of the Gross enrolment ratio (%) of Low & middle income in 1993 to that in 1997?
Your answer should be compact. 1.01. What is the ratio of the Gross enrolment ratio (%) in Lebanon in 1993 to that in 1997?
Offer a very short reply. 0.91. What is the ratio of the Gross enrolment ratio (%) in Paraguay in 1993 to that in 1997?
Make the answer very short. 0.95. What is the ratio of the Gross enrolment ratio (%) of Tunisia in 1993 to that in 1997?
Keep it short and to the point. 0.98. What is the ratio of the Gross enrolment ratio (%) in Low & middle income in 1993 to that in 1998?
Keep it short and to the point. 1.01. What is the ratio of the Gross enrolment ratio (%) in Lebanon in 1993 to that in 1998?
Offer a terse response. 0.87. What is the ratio of the Gross enrolment ratio (%) in Paraguay in 1993 to that in 1998?
Make the answer very short. 0.91. What is the ratio of the Gross enrolment ratio (%) of Tunisia in 1993 to that in 1998?
Your response must be concise. 0.97. What is the ratio of the Gross enrolment ratio (%) of Lebanon in 1994 to that in 1995?
Provide a succinct answer. 0.99. What is the ratio of the Gross enrolment ratio (%) of Paraguay in 1994 to that in 1995?
Ensure brevity in your answer.  0.98. What is the ratio of the Gross enrolment ratio (%) of Tunisia in 1994 to that in 1995?
Provide a short and direct response. 0.99. What is the ratio of the Gross enrolment ratio (%) in Low & middle income in 1994 to that in 1996?
Offer a very short reply. 1.01. What is the ratio of the Gross enrolment ratio (%) in Lebanon in 1994 to that in 1996?
Provide a succinct answer. 0.98. What is the ratio of the Gross enrolment ratio (%) of Paraguay in 1994 to that in 1996?
Offer a terse response. 0.95. What is the ratio of the Gross enrolment ratio (%) in Tunisia in 1994 to that in 1996?
Your answer should be very brief. 0.99. What is the ratio of the Gross enrolment ratio (%) in Low & middle income in 1994 to that in 1997?
Ensure brevity in your answer.  1.01. What is the ratio of the Gross enrolment ratio (%) in Lebanon in 1994 to that in 1997?
Provide a succinct answer. 0.94. What is the ratio of the Gross enrolment ratio (%) of Paraguay in 1994 to that in 1997?
Provide a succinct answer. 0.95. What is the ratio of the Gross enrolment ratio (%) in Low & middle income in 1994 to that in 1998?
Provide a short and direct response. 1.01. What is the ratio of the Gross enrolment ratio (%) in Lebanon in 1994 to that in 1998?
Make the answer very short. 0.9. What is the ratio of the Gross enrolment ratio (%) in Paraguay in 1994 to that in 1998?
Make the answer very short. 0.91. What is the ratio of the Gross enrolment ratio (%) of Tunisia in 1994 to that in 1998?
Provide a succinct answer. 0.99. What is the ratio of the Gross enrolment ratio (%) in Low & middle income in 1995 to that in 1996?
Ensure brevity in your answer.  1.01. What is the ratio of the Gross enrolment ratio (%) in Lebanon in 1995 to that in 1996?
Offer a terse response. 0.99. What is the ratio of the Gross enrolment ratio (%) of Paraguay in 1995 to that in 1996?
Keep it short and to the point. 0.97. What is the ratio of the Gross enrolment ratio (%) in Tunisia in 1995 to that in 1996?
Offer a very short reply. 1. What is the ratio of the Gross enrolment ratio (%) in Low & middle income in 1995 to that in 1997?
Your answer should be very brief. 1.01. What is the ratio of the Gross enrolment ratio (%) in Lebanon in 1995 to that in 1997?
Keep it short and to the point. 0.95. What is the ratio of the Gross enrolment ratio (%) of Paraguay in 1995 to that in 1997?
Provide a succinct answer. 0.98. What is the ratio of the Gross enrolment ratio (%) in Tunisia in 1995 to that in 1997?
Your answer should be compact. 1.01. What is the ratio of the Gross enrolment ratio (%) in Low & middle income in 1995 to that in 1998?
Your answer should be compact. 1.01. What is the ratio of the Gross enrolment ratio (%) in Paraguay in 1995 to that in 1998?
Ensure brevity in your answer.  0.93. What is the ratio of the Gross enrolment ratio (%) in Low & middle income in 1996 to that in 1997?
Your answer should be very brief. 1. What is the ratio of the Gross enrolment ratio (%) of Lebanon in 1996 to that in 1997?
Keep it short and to the point. 0.96. What is the ratio of the Gross enrolment ratio (%) of Tunisia in 1996 to that in 1997?
Your answer should be compact. 1.01. What is the ratio of the Gross enrolment ratio (%) of Low & middle income in 1996 to that in 1998?
Keep it short and to the point. 1. What is the ratio of the Gross enrolment ratio (%) of Paraguay in 1996 to that in 1998?
Give a very brief answer. 0.96. What is the ratio of the Gross enrolment ratio (%) in Low & middle income in 1997 to that in 1998?
Provide a short and direct response. 1. What is the ratio of the Gross enrolment ratio (%) of Lebanon in 1997 to that in 1998?
Your answer should be very brief. 0.95. What is the ratio of the Gross enrolment ratio (%) of Paraguay in 1997 to that in 1998?
Ensure brevity in your answer.  0.96. What is the ratio of the Gross enrolment ratio (%) in Tunisia in 1997 to that in 1998?
Give a very brief answer. 0.99. What is the difference between the highest and the second highest Gross enrolment ratio (%) in Low & middle income?
Keep it short and to the point. 0.11. What is the difference between the highest and the second highest Gross enrolment ratio (%) of Lebanon?
Offer a very short reply. 5.78. What is the difference between the highest and the second highest Gross enrolment ratio (%) in Paraguay?
Provide a short and direct response. 5.39. What is the difference between the highest and the second highest Gross enrolment ratio (%) of Tunisia?
Your answer should be compact. 0.05. What is the difference between the highest and the lowest Gross enrolment ratio (%) in Low & middle income?
Offer a terse response. 1.28. What is the difference between the highest and the lowest Gross enrolment ratio (%) of Lebanon?
Offer a very short reply. 16.76. What is the difference between the highest and the lowest Gross enrolment ratio (%) of Paraguay?
Give a very brief answer. 11.05. What is the difference between the highest and the lowest Gross enrolment ratio (%) in Tunisia?
Make the answer very short. 3.22. 